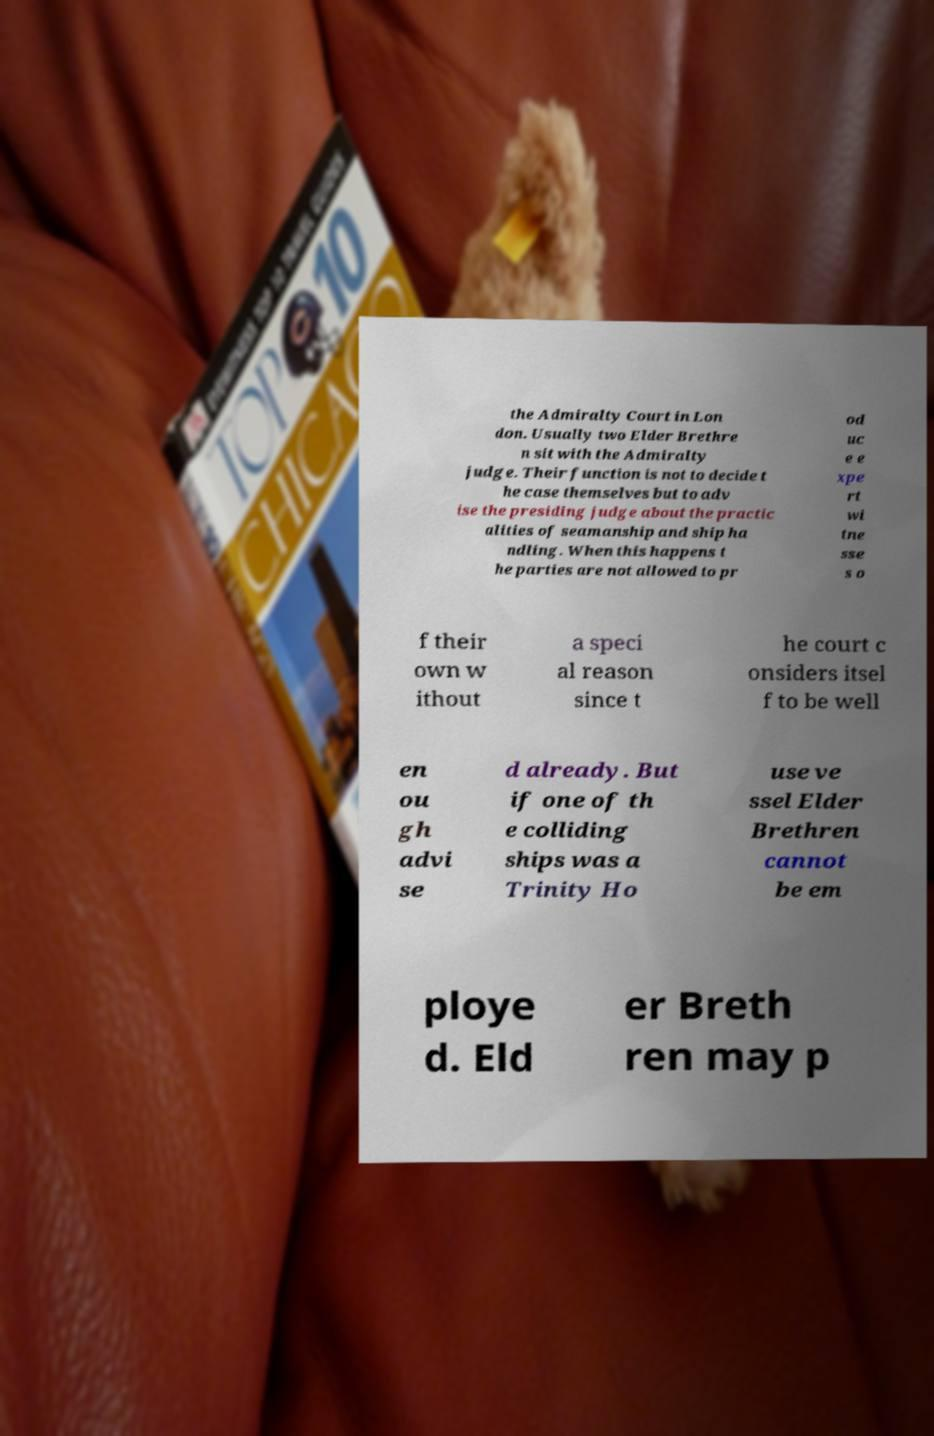There's text embedded in this image that I need extracted. Can you transcribe it verbatim? the Admiralty Court in Lon don. Usually two Elder Brethre n sit with the Admiralty judge. Their function is not to decide t he case themselves but to adv ise the presiding judge about the practic alities of seamanship and ship ha ndling. When this happens t he parties are not allowed to pr od uc e e xpe rt wi tne sse s o f their own w ithout a speci al reason since t he court c onsiders itsel f to be well en ou gh advi se d already. But if one of th e colliding ships was a Trinity Ho use ve ssel Elder Brethren cannot be em ploye d. Eld er Breth ren may p 